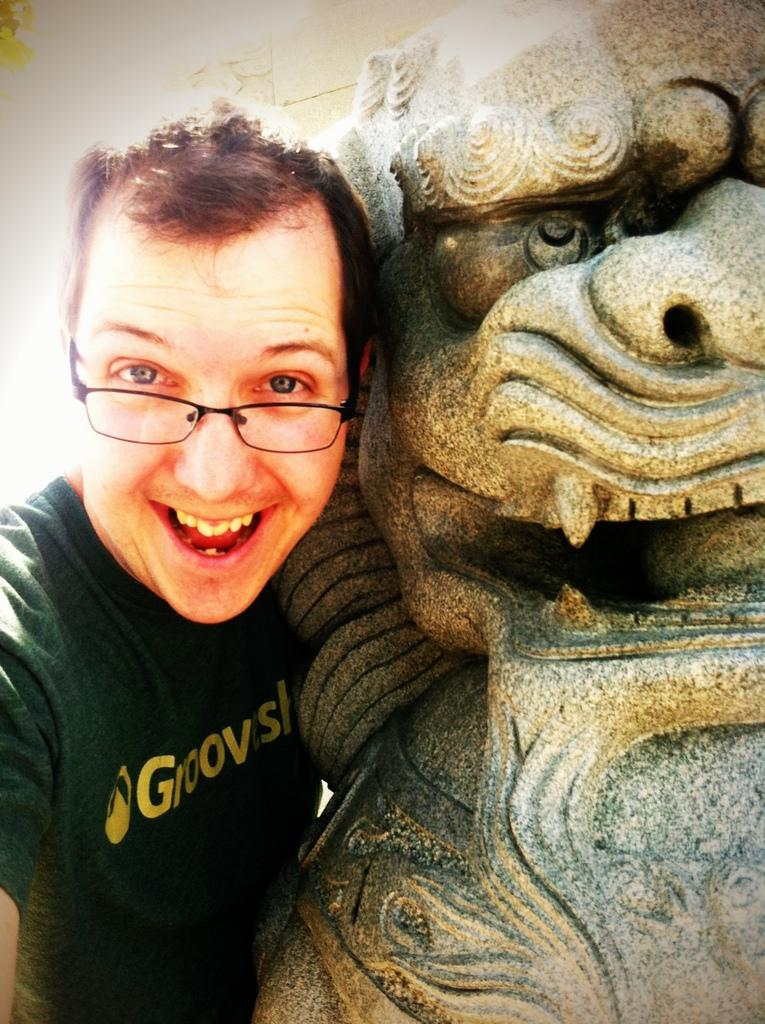Who is present in the image? There is a man in the image. What is the man doing or standing near in the image? The man is beside a sculpture. What type of scissors can be seen cutting the root in the image? There are no scissors or roots present in the image; it features a man standing beside a sculpture. 